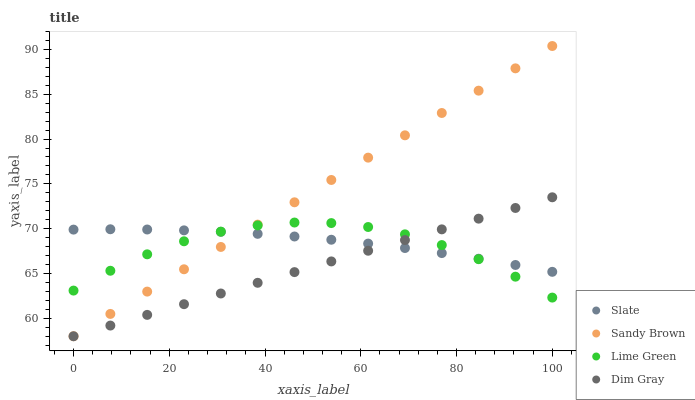Does Dim Gray have the minimum area under the curve?
Answer yes or no. Yes. Does Sandy Brown have the maximum area under the curve?
Answer yes or no. Yes. Does Slate have the minimum area under the curve?
Answer yes or no. No. Does Slate have the maximum area under the curve?
Answer yes or no. No. Is Dim Gray the smoothest?
Answer yes or no. Yes. Is Lime Green the roughest?
Answer yes or no. Yes. Is Slate the smoothest?
Answer yes or no. No. Is Slate the roughest?
Answer yes or no. No. Does Dim Gray have the lowest value?
Answer yes or no. Yes. Does Slate have the lowest value?
Answer yes or no. No. Does Sandy Brown have the highest value?
Answer yes or no. Yes. Does Dim Gray have the highest value?
Answer yes or no. No. Does Slate intersect Dim Gray?
Answer yes or no. Yes. Is Slate less than Dim Gray?
Answer yes or no. No. Is Slate greater than Dim Gray?
Answer yes or no. No. 